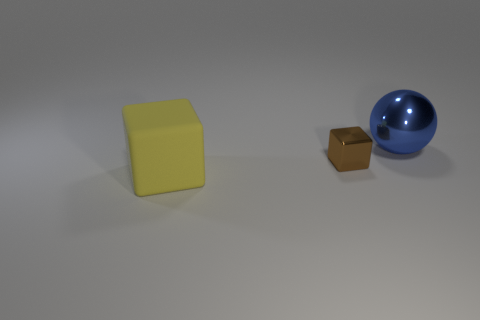Add 1 brown blocks. How many objects exist? 4 Subtract all balls. How many objects are left? 2 Add 2 large blue spheres. How many large blue spheres exist? 3 Subtract 0 gray cylinders. How many objects are left? 3 Subtract all large blue metallic things. Subtract all red cubes. How many objects are left? 2 Add 3 large blue metallic spheres. How many large blue metallic spheres are left? 4 